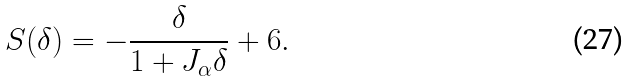<formula> <loc_0><loc_0><loc_500><loc_500>S ( \delta ) = - \frac { \delta } { 1 + J _ { \alpha } \delta } + 6 .</formula> 